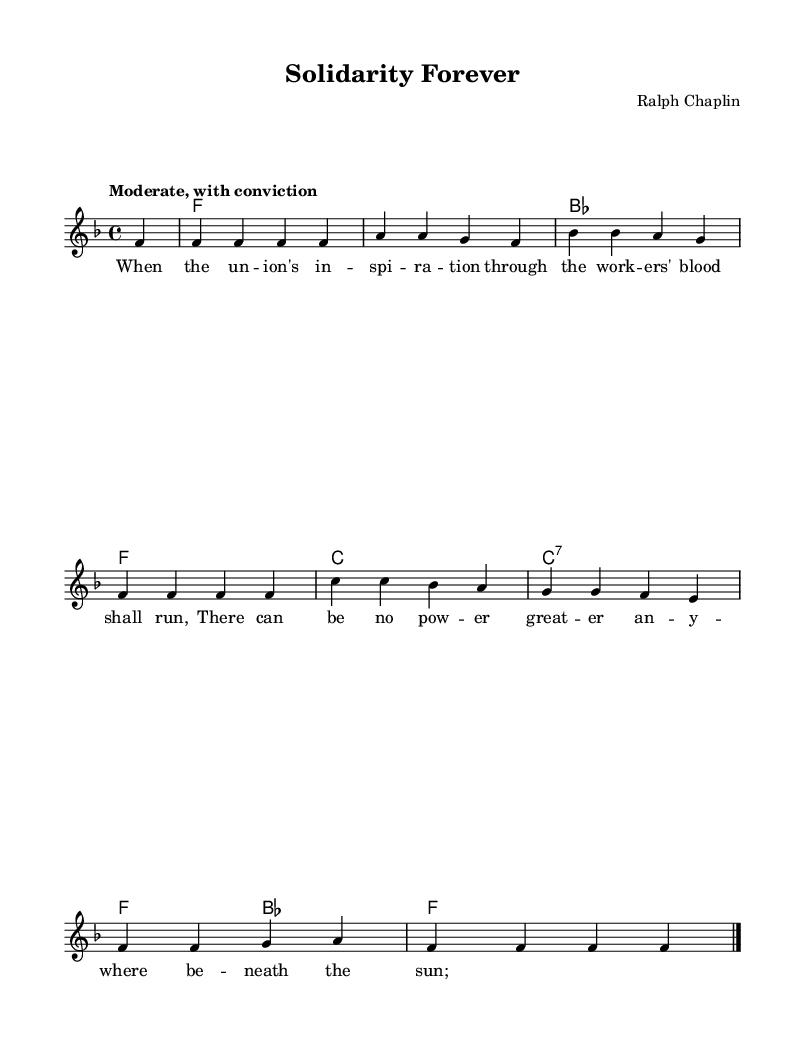What is the key signature of this music? The key signature is F major, which has one flat (B flat). This can be seen at the beginning of the staff where the flat symbol for B is placed.
Answer: F major What is the time signature of this music? The time signature is 4/4, indicated at the beginning of the score, which shows four beats per measure.
Answer: 4/4 What is the tempo marking for this piece? The tempo marking is "Moderate, with conviction," which suggests a moderate speed that conveys a sense of determination. This is written above the staff.
Answer: Moderate, with conviction How many measures are there in the score? Counting the measures in the melody and harmonies sections, there are a total of eight measures present in the score.
Answer: Eight What is the title of this piece? The title is "Solidarity Forever," which is prominently displayed at the top of the sheet music.
Answer: Solidarity Forever Who is the composer of this piece? The composer is Ralph Chaplin, as stated in the header of the sheet music.
Answer: Ralph Chaplin What theme is expressed in the lyrics of the song? The theme expressed in the lyrics is workers' rights and unions, highlighting the importance of unity and strength among workers. This theme can be inferred from the lyrics, which discuss the workers' spirit.
Answer: Workers' rights 